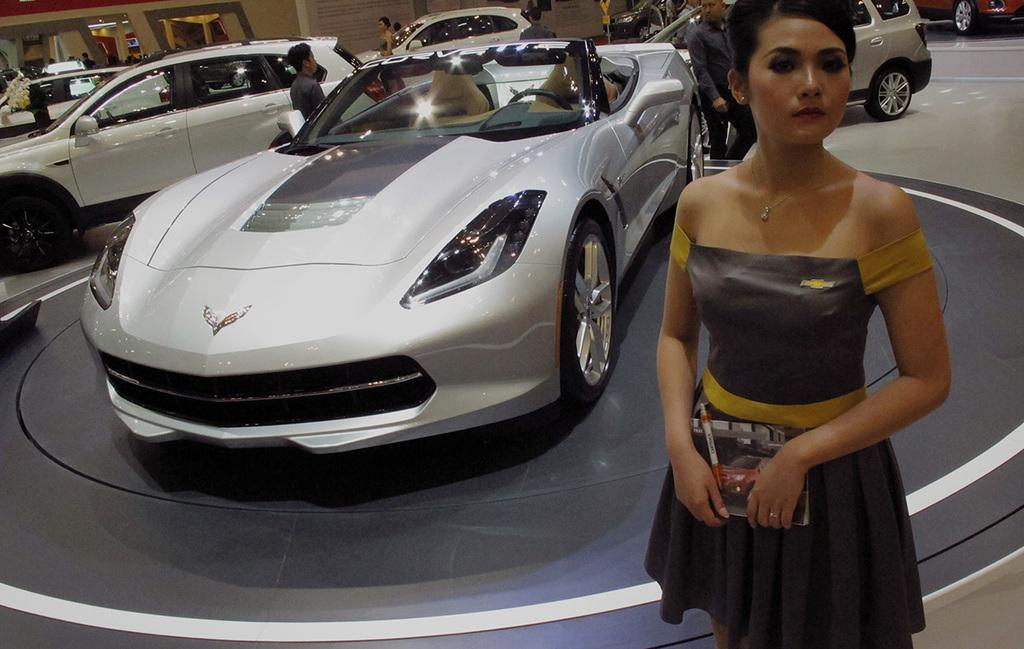What is the main subject of the image? The main subject of the image is a group of vehicles. Are there any people present in the image? Yes, there are people on the ground in the image. What can be seen in the background of the image? There is a wall visible in the background of the image. What type of bead is being used to decorate the vehicles in the image? There is no mention of beads or any decorative elements in the image; it only features a group of vehicles and people on the ground. 